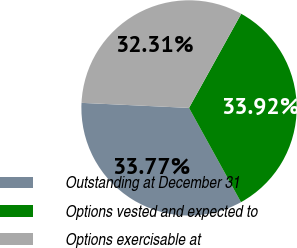Convert chart to OTSL. <chart><loc_0><loc_0><loc_500><loc_500><pie_chart><fcel>Outstanding at December 31<fcel>Options vested and expected to<fcel>Options exercisable at<nl><fcel>33.77%<fcel>33.92%<fcel>32.31%<nl></chart> 